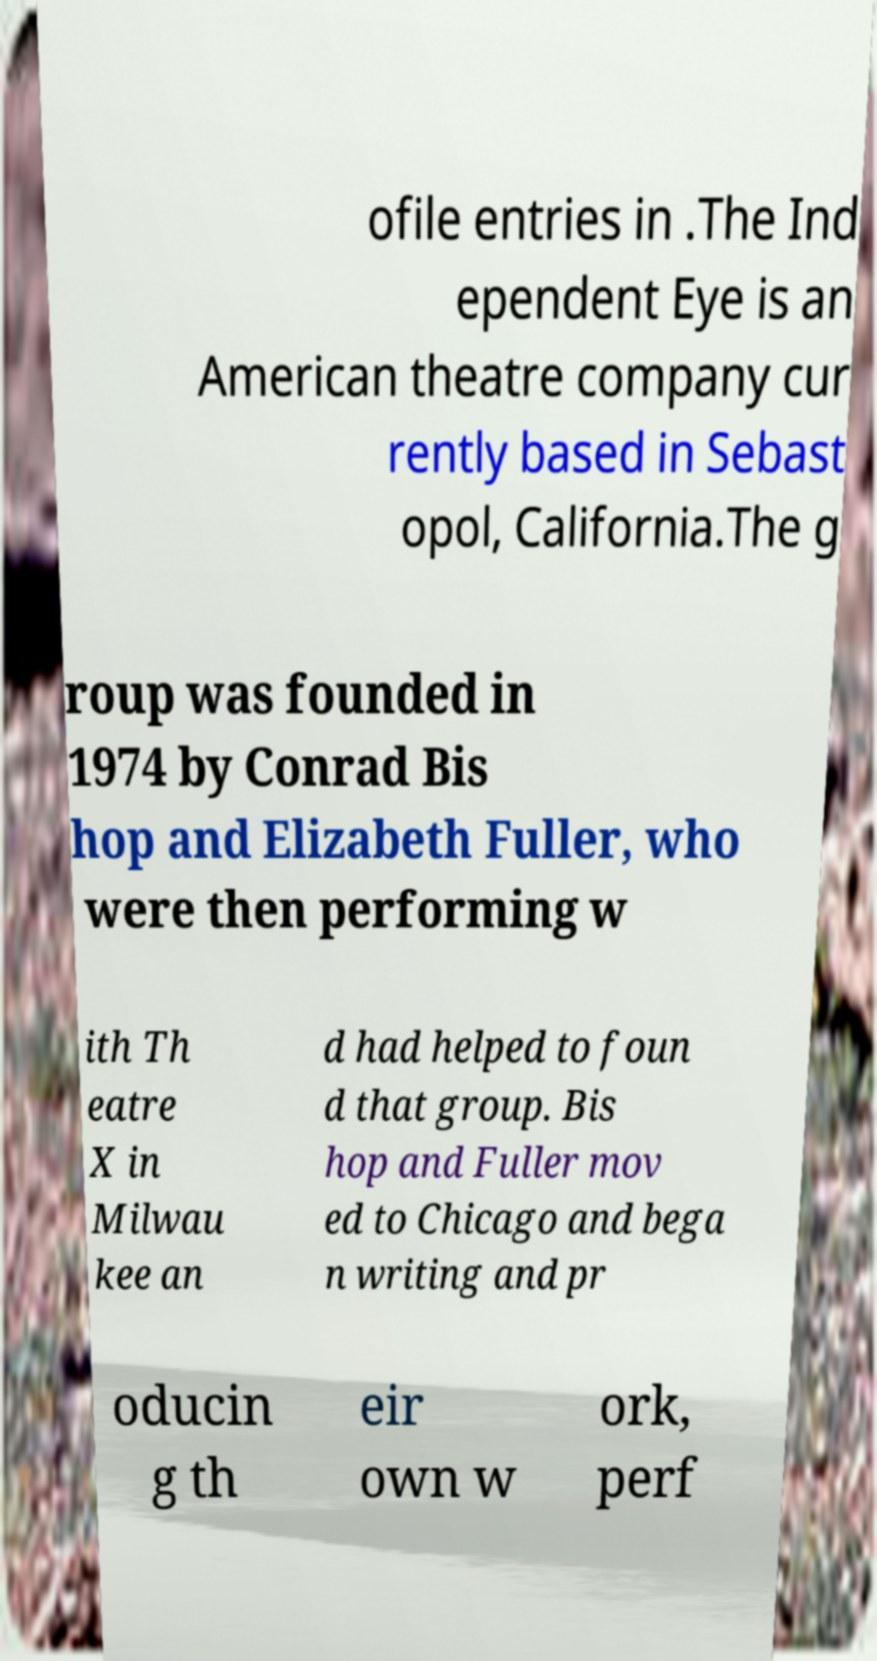I need the written content from this picture converted into text. Can you do that? ofile entries in .The Ind ependent Eye is an American theatre company cur rently based in Sebast opol, California.The g roup was founded in 1974 by Conrad Bis hop and Elizabeth Fuller, who were then performing w ith Th eatre X in Milwau kee an d had helped to foun d that group. Bis hop and Fuller mov ed to Chicago and bega n writing and pr oducin g th eir own w ork, perf 